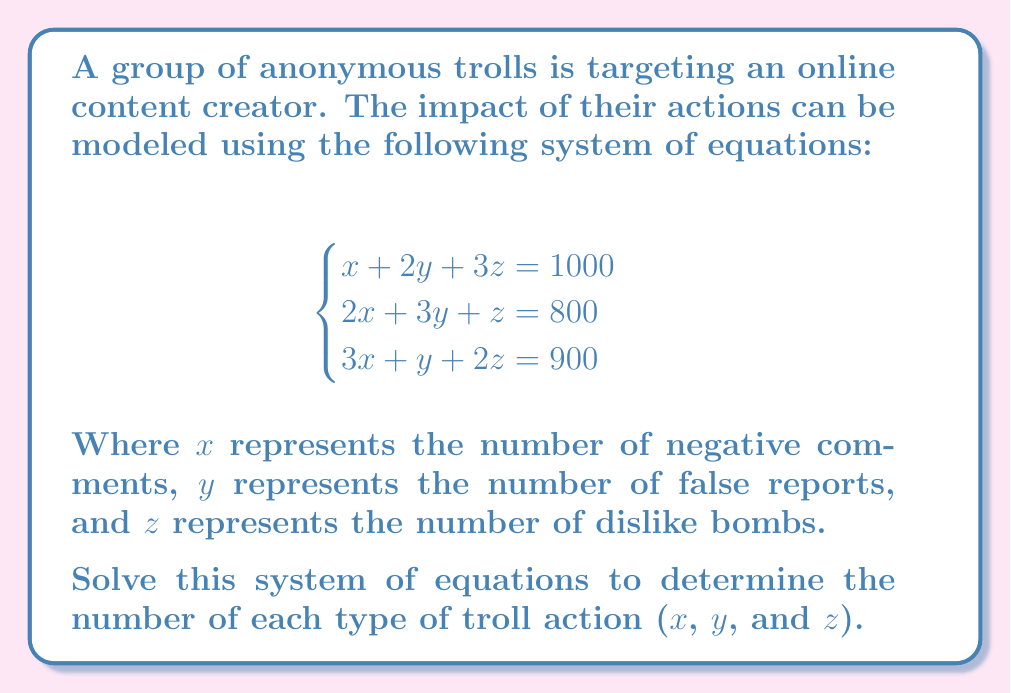Help me with this question. To solve this system of equations, we can use the elimination method:

1) First, let's eliminate $x$ by multiplying the first equation by 2 and subtracting it from the second equation:

   $$2(x + 2y + 3z = 1000) \Rightarrow 2x + 4y + 6z = 2000$$
   $$2x + 3y + z = 800$$
   
   Subtracting these equations:
   $$y + 5z = 1200 \quad \text{(Equation 4)}$$

2) Now, let's eliminate $x$ by multiplying the first equation by 3 and subtracting it from the third equation:

   $$3(x + 2y + 3z = 1000) \Rightarrow 3x + 6y + 9z = 3000$$
   $$3x + y + 2z = 900$$
   
   Subtracting these equations:
   $$5y + 7z = 2100 \quad \text{(Equation 5)}$$

3) Now we have a system of two equations with two unknowns (y and z):

   $$\begin{cases}
   y + 5z = 1200 \\
   5y + 7z = 2100
   \end{cases}$$

4) Multiply the first equation by 5 and subtract from the second:

   $$5y + 25z = 6000$$
   $$5y + 7z = 2100$$
   
   Subtracting:
   $$18z = 3900$$

5) Solve for $z$:
   $$z = \frac{3900}{18} = 216.6666... \approx 217$$

6) Substitute this value of $z$ back into Equation 4:

   $$y + 5(217) = 1200$$
   $$y + 1085 = 1200$$
   $$y = 115$$

7) Now that we have $y$ and $z$, we can substitute these into the first original equation to find $x$:

   $$x + 2(115) + 3(217) = 1000$$
   $$x + 230 + 651 = 1000$$
   $$x = 119$$

Therefore, the solution is $x = 119$, $y = 115$, and $z = 217$.
Answer: $x = 119$ negative comments, $y = 115$ false reports, $z = 217$ dislike bombs 